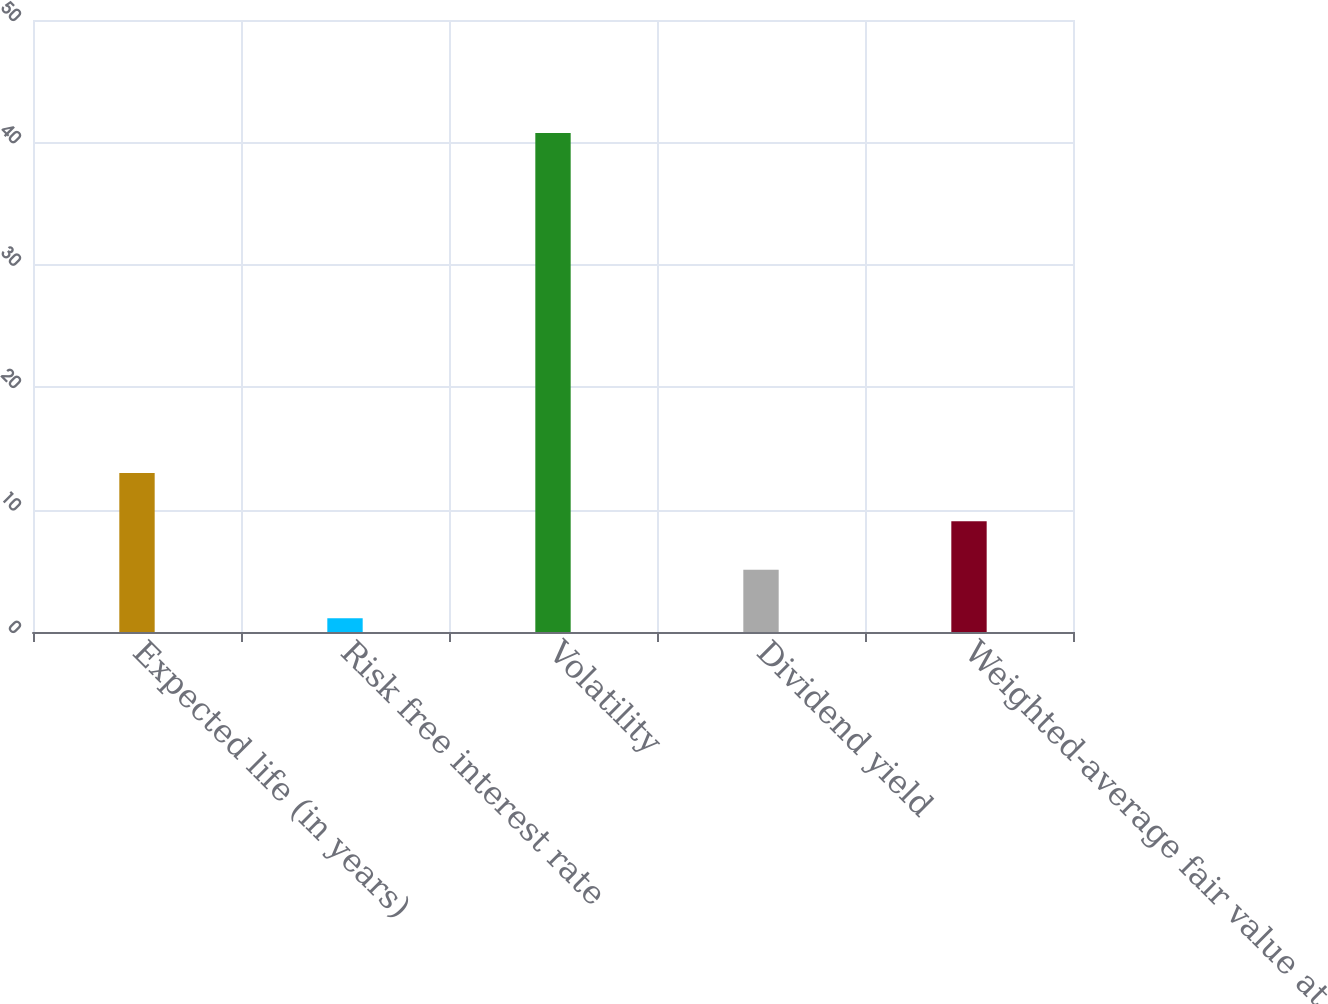<chart> <loc_0><loc_0><loc_500><loc_500><bar_chart><fcel>Expected life (in years)<fcel>Risk free interest rate<fcel>Volatility<fcel>Dividend yield<fcel>Weighted-average fair value at<nl><fcel>13<fcel>1.12<fcel>40.76<fcel>5.08<fcel>9.04<nl></chart> 